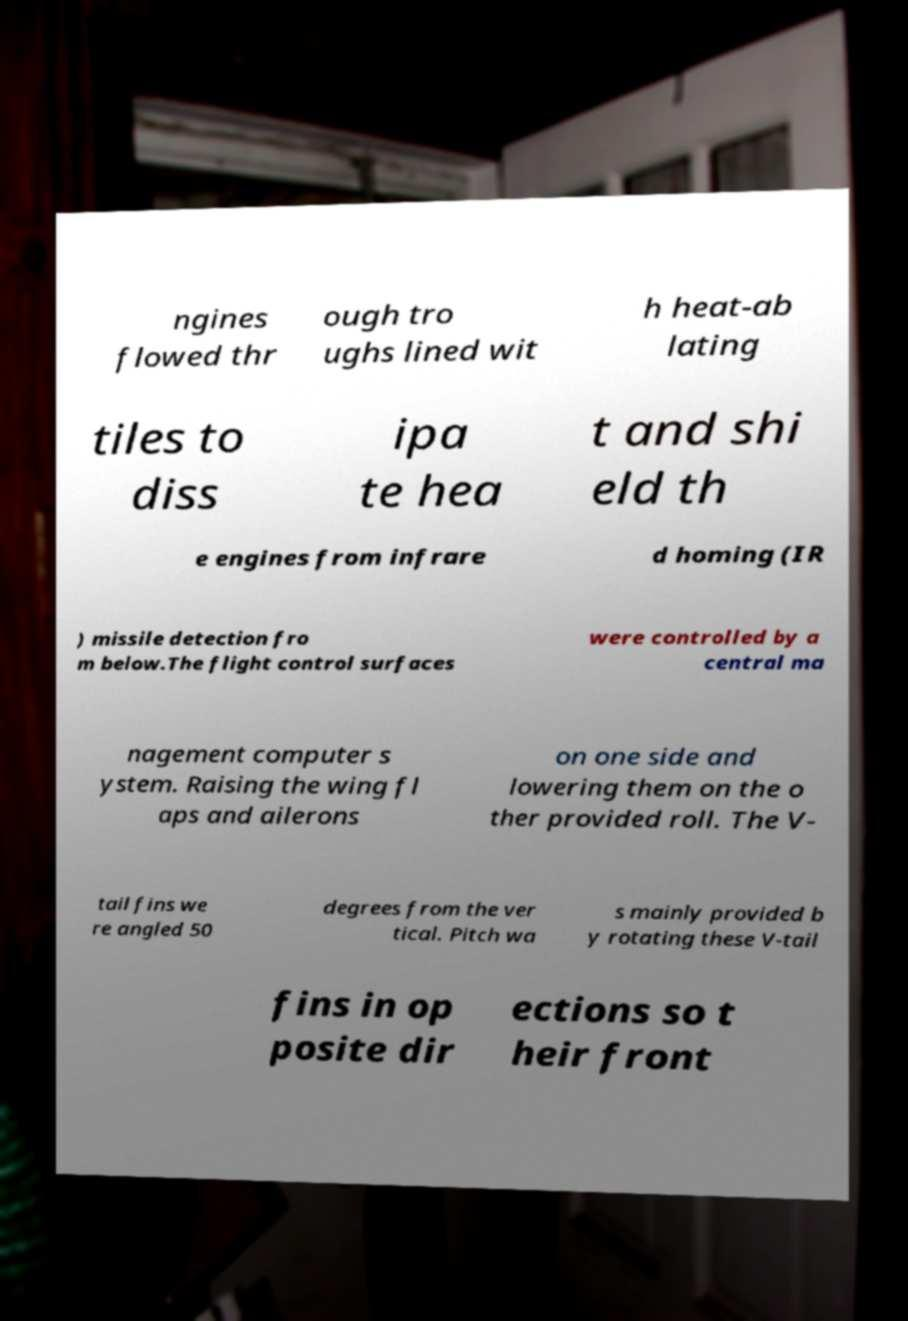There's text embedded in this image that I need extracted. Can you transcribe it verbatim? ngines flowed thr ough tro ughs lined wit h heat-ab lating tiles to diss ipa te hea t and shi eld th e engines from infrare d homing (IR ) missile detection fro m below.The flight control surfaces were controlled by a central ma nagement computer s ystem. Raising the wing fl aps and ailerons on one side and lowering them on the o ther provided roll. The V- tail fins we re angled 50 degrees from the ver tical. Pitch wa s mainly provided b y rotating these V-tail fins in op posite dir ections so t heir front 